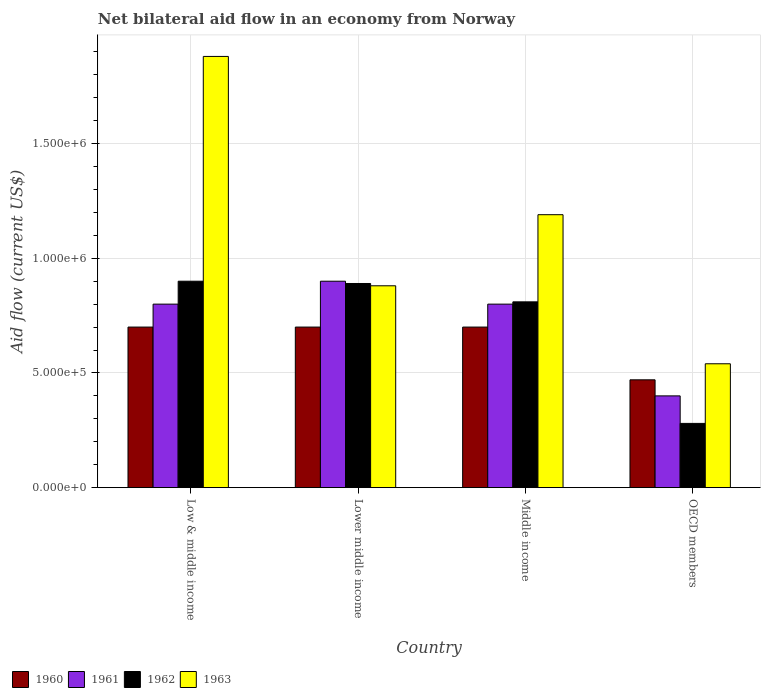How many groups of bars are there?
Your answer should be compact. 4. Are the number of bars per tick equal to the number of legend labels?
Offer a terse response. Yes. What is the net bilateral aid flow in 1963 in Low & middle income?
Give a very brief answer. 1.88e+06. Across all countries, what is the minimum net bilateral aid flow in 1960?
Provide a succinct answer. 4.70e+05. In which country was the net bilateral aid flow in 1962 maximum?
Keep it short and to the point. Low & middle income. In which country was the net bilateral aid flow in 1960 minimum?
Your answer should be compact. OECD members. What is the total net bilateral aid flow in 1963 in the graph?
Your response must be concise. 4.49e+06. What is the difference between the net bilateral aid flow in 1963 in Middle income and that in OECD members?
Offer a terse response. 6.50e+05. What is the average net bilateral aid flow in 1963 per country?
Your answer should be compact. 1.12e+06. What is the difference between the net bilateral aid flow of/in 1963 and net bilateral aid flow of/in 1960 in Low & middle income?
Offer a very short reply. 1.18e+06. In how many countries, is the net bilateral aid flow in 1960 greater than 1000000 US$?
Your answer should be compact. 0. What is the ratio of the net bilateral aid flow in 1962 in Low & middle income to that in OECD members?
Your response must be concise. 3.21. Is the net bilateral aid flow in 1960 in Low & middle income less than that in Lower middle income?
Your answer should be compact. No. In how many countries, is the net bilateral aid flow in 1961 greater than the average net bilateral aid flow in 1961 taken over all countries?
Your answer should be compact. 3. Is the sum of the net bilateral aid flow in 1960 in Middle income and OECD members greater than the maximum net bilateral aid flow in 1962 across all countries?
Give a very brief answer. Yes. Is it the case that in every country, the sum of the net bilateral aid flow in 1962 and net bilateral aid flow in 1963 is greater than the sum of net bilateral aid flow in 1961 and net bilateral aid flow in 1960?
Your answer should be very brief. No. What does the 2nd bar from the left in Middle income represents?
Offer a very short reply. 1961. What does the 2nd bar from the right in Lower middle income represents?
Offer a very short reply. 1962. How many bars are there?
Keep it short and to the point. 16. Are all the bars in the graph horizontal?
Provide a short and direct response. No. What is the difference between two consecutive major ticks on the Y-axis?
Offer a terse response. 5.00e+05. Where does the legend appear in the graph?
Offer a terse response. Bottom left. How many legend labels are there?
Provide a short and direct response. 4. How are the legend labels stacked?
Your response must be concise. Horizontal. What is the title of the graph?
Make the answer very short. Net bilateral aid flow in an economy from Norway. What is the label or title of the Y-axis?
Your answer should be compact. Aid flow (current US$). What is the Aid flow (current US$) in 1960 in Low & middle income?
Offer a very short reply. 7.00e+05. What is the Aid flow (current US$) of 1963 in Low & middle income?
Your answer should be compact. 1.88e+06. What is the Aid flow (current US$) of 1962 in Lower middle income?
Your response must be concise. 8.90e+05. What is the Aid flow (current US$) of 1963 in Lower middle income?
Ensure brevity in your answer.  8.80e+05. What is the Aid flow (current US$) of 1961 in Middle income?
Provide a short and direct response. 8.00e+05. What is the Aid flow (current US$) in 1962 in Middle income?
Your answer should be compact. 8.10e+05. What is the Aid flow (current US$) in 1963 in Middle income?
Provide a succinct answer. 1.19e+06. What is the Aid flow (current US$) of 1961 in OECD members?
Keep it short and to the point. 4.00e+05. What is the Aid flow (current US$) of 1962 in OECD members?
Your response must be concise. 2.80e+05. What is the Aid flow (current US$) of 1963 in OECD members?
Ensure brevity in your answer.  5.40e+05. Across all countries, what is the maximum Aid flow (current US$) in 1961?
Provide a short and direct response. 9.00e+05. Across all countries, what is the maximum Aid flow (current US$) in 1962?
Offer a terse response. 9.00e+05. Across all countries, what is the maximum Aid flow (current US$) of 1963?
Your answer should be compact. 1.88e+06. Across all countries, what is the minimum Aid flow (current US$) of 1961?
Offer a very short reply. 4.00e+05. Across all countries, what is the minimum Aid flow (current US$) in 1963?
Provide a succinct answer. 5.40e+05. What is the total Aid flow (current US$) in 1960 in the graph?
Offer a terse response. 2.57e+06. What is the total Aid flow (current US$) of 1961 in the graph?
Make the answer very short. 2.90e+06. What is the total Aid flow (current US$) of 1962 in the graph?
Offer a very short reply. 2.88e+06. What is the total Aid flow (current US$) of 1963 in the graph?
Provide a short and direct response. 4.49e+06. What is the difference between the Aid flow (current US$) of 1963 in Low & middle income and that in Lower middle income?
Keep it short and to the point. 1.00e+06. What is the difference between the Aid flow (current US$) in 1960 in Low & middle income and that in Middle income?
Keep it short and to the point. 0. What is the difference between the Aid flow (current US$) in 1963 in Low & middle income and that in Middle income?
Your response must be concise. 6.90e+05. What is the difference between the Aid flow (current US$) of 1961 in Low & middle income and that in OECD members?
Your response must be concise. 4.00e+05. What is the difference between the Aid flow (current US$) in 1962 in Low & middle income and that in OECD members?
Offer a terse response. 6.20e+05. What is the difference between the Aid flow (current US$) in 1963 in Low & middle income and that in OECD members?
Provide a short and direct response. 1.34e+06. What is the difference between the Aid flow (current US$) in 1963 in Lower middle income and that in Middle income?
Ensure brevity in your answer.  -3.10e+05. What is the difference between the Aid flow (current US$) in 1960 in Lower middle income and that in OECD members?
Your response must be concise. 2.30e+05. What is the difference between the Aid flow (current US$) in 1962 in Lower middle income and that in OECD members?
Your response must be concise. 6.10e+05. What is the difference between the Aid flow (current US$) in 1963 in Lower middle income and that in OECD members?
Your answer should be compact. 3.40e+05. What is the difference between the Aid flow (current US$) of 1960 in Middle income and that in OECD members?
Your answer should be very brief. 2.30e+05. What is the difference between the Aid flow (current US$) in 1961 in Middle income and that in OECD members?
Make the answer very short. 4.00e+05. What is the difference between the Aid flow (current US$) in 1962 in Middle income and that in OECD members?
Your answer should be very brief. 5.30e+05. What is the difference between the Aid flow (current US$) of 1963 in Middle income and that in OECD members?
Your answer should be very brief. 6.50e+05. What is the difference between the Aid flow (current US$) in 1960 in Low & middle income and the Aid flow (current US$) in 1961 in Lower middle income?
Offer a terse response. -2.00e+05. What is the difference between the Aid flow (current US$) of 1960 in Low & middle income and the Aid flow (current US$) of 1962 in Lower middle income?
Your response must be concise. -1.90e+05. What is the difference between the Aid flow (current US$) in 1960 in Low & middle income and the Aid flow (current US$) in 1963 in Lower middle income?
Ensure brevity in your answer.  -1.80e+05. What is the difference between the Aid flow (current US$) of 1961 in Low & middle income and the Aid flow (current US$) of 1962 in Lower middle income?
Give a very brief answer. -9.00e+04. What is the difference between the Aid flow (current US$) of 1961 in Low & middle income and the Aid flow (current US$) of 1963 in Lower middle income?
Ensure brevity in your answer.  -8.00e+04. What is the difference between the Aid flow (current US$) in 1962 in Low & middle income and the Aid flow (current US$) in 1963 in Lower middle income?
Your response must be concise. 2.00e+04. What is the difference between the Aid flow (current US$) of 1960 in Low & middle income and the Aid flow (current US$) of 1961 in Middle income?
Make the answer very short. -1.00e+05. What is the difference between the Aid flow (current US$) of 1960 in Low & middle income and the Aid flow (current US$) of 1963 in Middle income?
Your response must be concise. -4.90e+05. What is the difference between the Aid flow (current US$) in 1961 in Low & middle income and the Aid flow (current US$) in 1963 in Middle income?
Make the answer very short. -3.90e+05. What is the difference between the Aid flow (current US$) in 1962 in Low & middle income and the Aid flow (current US$) in 1963 in Middle income?
Keep it short and to the point. -2.90e+05. What is the difference between the Aid flow (current US$) in 1960 in Low & middle income and the Aid flow (current US$) in 1962 in OECD members?
Your answer should be very brief. 4.20e+05. What is the difference between the Aid flow (current US$) in 1961 in Low & middle income and the Aid flow (current US$) in 1962 in OECD members?
Ensure brevity in your answer.  5.20e+05. What is the difference between the Aid flow (current US$) in 1961 in Low & middle income and the Aid flow (current US$) in 1963 in OECD members?
Your answer should be compact. 2.60e+05. What is the difference between the Aid flow (current US$) of 1962 in Low & middle income and the Aid flow (current US$) of 1963 in OECD members?
Give a very brief answer. 3.60e+05. What is the difference between the Aid flow (current US$) in 1960 in Lower middle income and the Aid flow (current US$) in 1963 in Middle income?
Your response must be concise. -4.90e+05. What is the difference between the Aid flow (current US$) in 1961 in Lower middle income and the Aid flow (current US$) in 1962 in Middle income?
Give a very brief answer. 9.00e+04. What is the difference between the Aid flow (current US$) of 1961 in Lower middle income and the Aid flow (current US$) of 1963 in Middle income?
Your response must be concise. -2.90e+05. What is the difference between the Aid flow (current US$) of 1962 in Lower middle income and the Aid flow (current US$) of 1963 in Middle income?
Offer a terse response. -3.00e+05. What is the difference between the Aid flow (current US$) in 1960 in Lower middle income and the Aid flow (current US$) in 1963 in OECD members?
Your answer should be compact. 1.60e+05. What is the difference between the Aid flow (current US$) in 1961 in Lower middle income and the Aid flow (current US$) in 1962 in OECD members?
Your response must be concise. 6.20e+05. What is the difference between the Aid flow (current US$) in 1961 in Lower middle income and the Aid flow (current US$) in 1963 in OECD members?
Make the answer very short. 3.60e+05. What is the difference between the Aid flow (current US$) of 1960 in Middle income and the Aid flow (current US$) of 1962 in OECD members?
Ensure brevity in your answer.  4.20e+05. What is the difference between the Aid flow (current US$) of 1961 in Middle income and the Aid flow (current US$) of 1962 in OECD members?
Your response must be concise. 5.20e+05. What is the average Aid flow (current US$) in 1960 per country?
Keep it short and to the point. 6.42e+05. What is the average Aid flow (current US$) in 1961 per country?
Your response must be concise. 7.25e+05. What is the average Aid flow (current US$) in 1962 per country?
Give a very brief answer. 7.20e+05. What is the average Aid flow (current US$) of 1963 per country?
Offer a terse response. 1.12e+06. What is the difference between the Aid flow (current US$) of 1960 and Aid flow (current US$) of 1961 in Low & middle income?
Your response must be concise. -1.00e+05. What is the difference between the Aid flow (current US$) of 1960 and Aid flow (current US$) of 1963 in Low & middle income?
Your answer should be compact. -1.18e+06. What is the difference between the Aid flow (current US$) in 1961 and Aid flow (current US$) in 1963 in Low & middle income?
Ensure brevity in your answer.  -1.08e+06. What is the difference between the Aid flow (current US$) of 1962 and Aid flow (current US$) of 1963 in Low & middle income?
Your response must be concise. -9.80e+05. What is the difference between the Aid flow (current US$) in 1961 and Aid flow (current US$) in 1963 in Lower middle income?
Give a very brief answer. 2.00e+04. What is the difference between the Aid flow (current US$) in 1960 and Aid flow (current US$) in 1963 in Middle income?
Your answer should be compact. -4.90e+05. What is the difference between the Aid flow (current US$) of 1961 and Aid flow (current US$) of 1963 in Middle income?
Offer a terse response. -3.90e+05. What is the difference between the Aid flow (current US$) in 1962 and Aid flow (current US$) in 1963 in Middle income?
Offer a terse response. -3.80e+05. What is the difference between the Aid flow (current US$) of 1960 and Aid flow (current US$) of 1961 in OECD members?
Make the answer very short. 7.00e+04. What is the difference between the Aid flow (current US$) of 1961 and Aid flow (current US$) of 1962 in OECD members?
Keep it short and to the point. 1.20e+05. What is the difference between the Aid flow (current US$) in 1961 and Aid flow (current US$) in 1963 in OECD members?
Your answer should be compact. -1.40e+05. What is the difference between the Aid flow (current US$) of 1962 and Aid flow (current US$) of 1963 in OECD members?
Your answer should be compact. -2.60e+05. What is the ratio of the Aid flow (current US$) in 1961 in Low & middle income to that in Lower middle income?
Offer a terse response. 0.89. What is the ratio of the Aid flow (current US$) of 1962 in Low & middle income to that in Lower middle income?
Make the answer very short. 1.01. What is the ratio of the Aid flow (current US$) of 1963 in Low & middle income to that in Lower middle income?
Keep it short and to the point. 2.14. What is the ratio of the Aid flow (current US$) of 1960 in Low & middle income to that in Middle income?
Make the answer very short. 1. What is the ratio of the Aid flow (current US$) of 1961 in Low & middle income to that in Middle income?
Your answer should be compact. 1. What is the ratio of the Aid flow (current US$) of 1963 in Low & middle income to that in Middle income?
Make the answer very short. 1.58. What is the ratio of the Aid flow (current US$) of 1960 in Low & middle income to that in OECD members?
Ensure brevity in your answer.  1.49. What is the ratio of the Aid flow (current US$) in 1962 in Low & middle income to that in OECD members?
Ensure brevity in your answer.  3.21. What is the ratio of the Aid flow (current US$) of 1963 in Low & middle income to that in OECD members?
Offer a terse response. 3.48. What is the ratio of the Aid flow (current US$) in 1960 in Lower middle income to that in Middle income?
Your response must be concise. 1. What is the ratio of the Aid flow (current US$) of 1961 in Lower middle income to that in Middle income?
Give a very brief answer. 1.12. What is the ratio of the Aid flow (current US$) in 1962 in Lower middle income to that in Middle income?
Provide a succinct answer. 1.1. What is the ratio of the Aid flow (current US$) in 1963 in Lower middle income to that in Middle income?
Provide a short and direct response. 0.74. What is the ratio of the Aid flow (current US$) of 1960 in Lower middle income to that in OECD members?
Your answer should be compact. 1.49. What is the ratio of the Aid flow (current US$) of 1961 in Lower middle income to that in OECD members?
Offer a very short reply. 2.25. What is the ratio of the Aid flow (current US$) of 1962 in Lower middle income to that in OECD members?
Your answer should be compact. 3.18. What is the ratio of the Aid flow (current US$) in 1963 in Lower middle income to that in OECD members?
Ensure brevity in your answer.  1.63. What is the ratio of the Aid flow (current US$) in 1960 in Middle income to that in OECD members?
Keep it short and to the point. 1.49. What is the ratio of the Aid flow (current US$) in 1961 in Middle income to that in OECD members?
Give a very brief answer. 2. What is the ratio of the Aid flow (current US$) of 1962 in Middle income to that in OECD members?
Provide a short and direct response. 2.89. What is the ratio of the Aid flow (current US$) of 1963 in Middle income to that in OECD members?
Your answer should be compact. 2.2. What is the difference between the highest and the second highest Aid flow (current US$) in 1962?
Your answer should be very brief. 10000. What is the difference between the highest and the second highest Aid flow (current US$) in 1963?
Provide a short and direct response. 6.90e+05. What is the difference between the highest and the lowest Aid flow (current US$) of 1960?
Your answer should be compact. 2.30e+05. What is the difference between the highest and the lowest Aid flow (current US$) of 1961?
Provide a short and direct response. 5.00e+05. What is the difference between the highest and the lowest Aid flow (current US$) of 1962?
Give a very brief answer. 6.20e+05. What is the difference between the highest and the lowest Aid flow (current US$) in 1963?
Keep it short and to the point. 1.34e+06. 